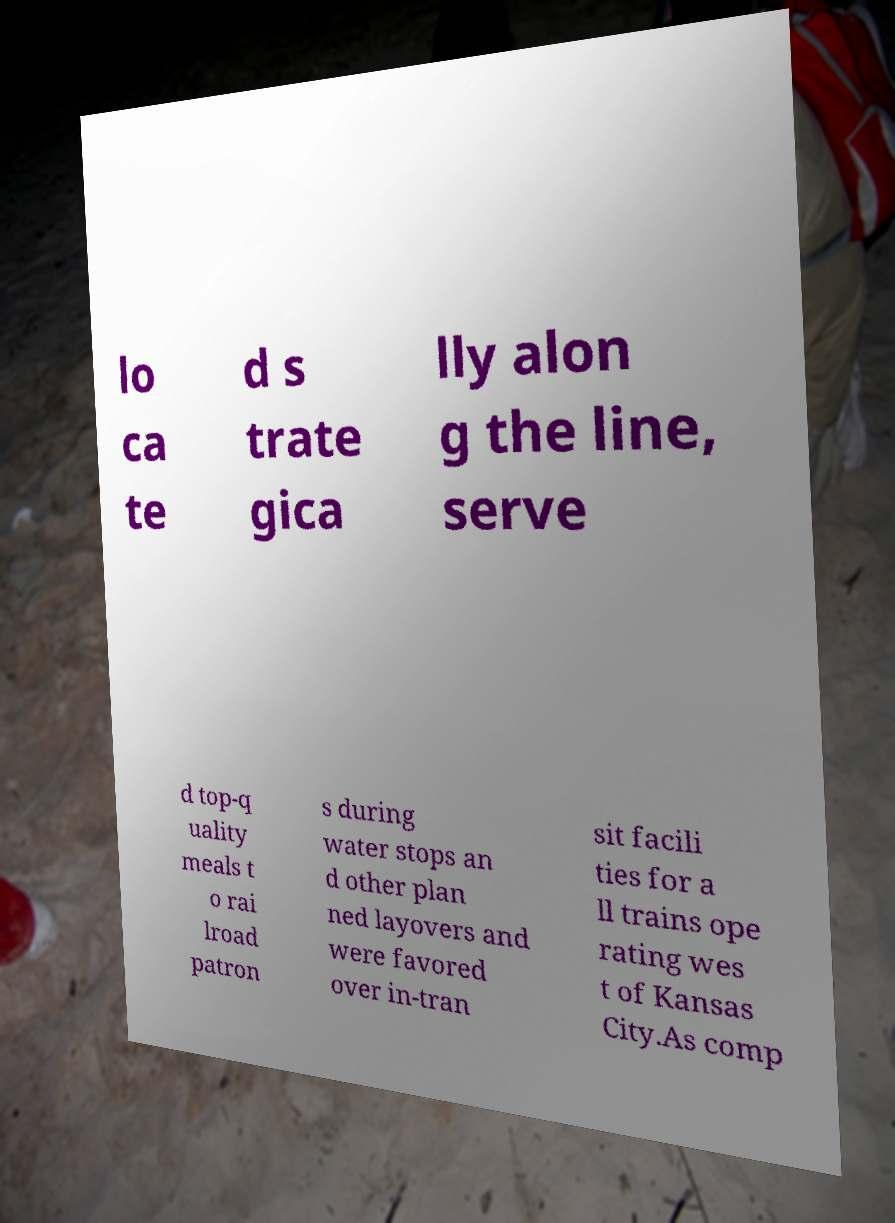There's text embedded in this image that I need extracted. Can you transcribe it verbatim? lo ca te d s trate gica lly alon g the line, serve d top-q uality meals t o rai lroad patron s during water stops an d other plan ned layovers and were favored over in-tran sit facili ties for a ll trains ope rating wes t of Kansas City.As comp 